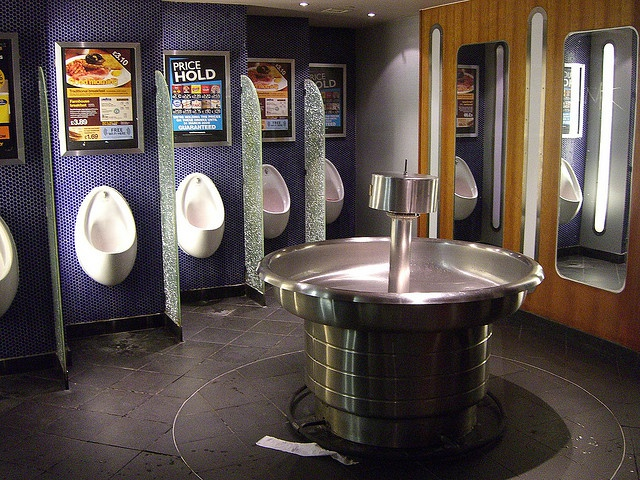Describe the objects in this image and their specific colors. I can see toilet in navy, white, gray, tan, and darkgray tones, toilet in navy, white, gray, tan, and darkgray tones, toilet in navy, darkgray, gray, and lightgray tones, toilet in navy, gray, darkgray, and black tones, and toilet in navy, gray, beige, and darkgreen tones in this image. 